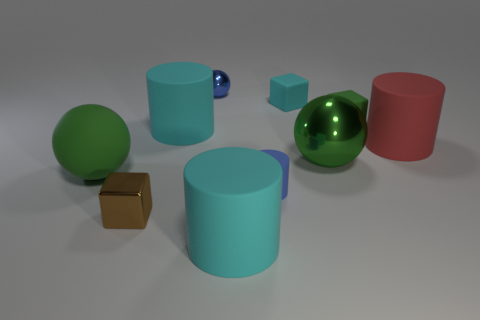What are the different materials that appear to be used in the various objects in this scene? The scene appears to include objects made from a variety of materials. The reflective characteristics suggest metals and maybe polished plastics. For instance, the green and red spheres along with the blue cylinder exhibit a matte finish, possibly indicating a plastic or painted surface, whereas the gold cube and the large metal sphere have a metallic sheen, indicating they could be made from polished metal. 